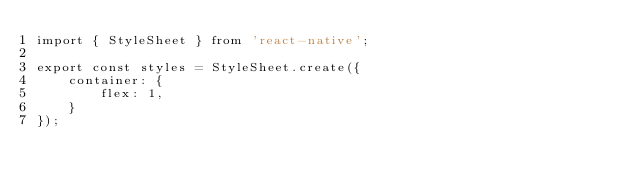Convert code to text. <code><loc_0><loc_0><loc_500><loc_500><_TypeScript_>import { StyleSheet } from 'react-native';

export const styles = StyleSheet.create({
	container: {
		flex: 1,
	}
});</code> 